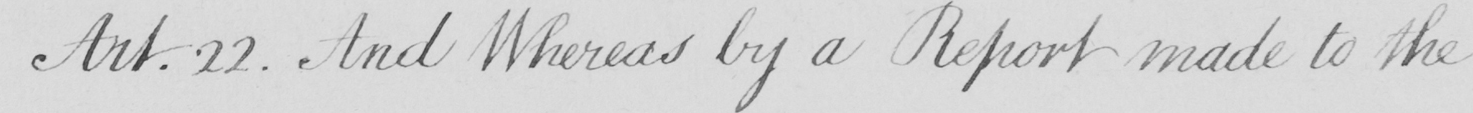What text is written in this handwritten line? Art . 22 . And Whereas by a Report made to the 